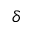<formula> <loc_0><loc_0><loc_500><loc_500>\delta</formula> 